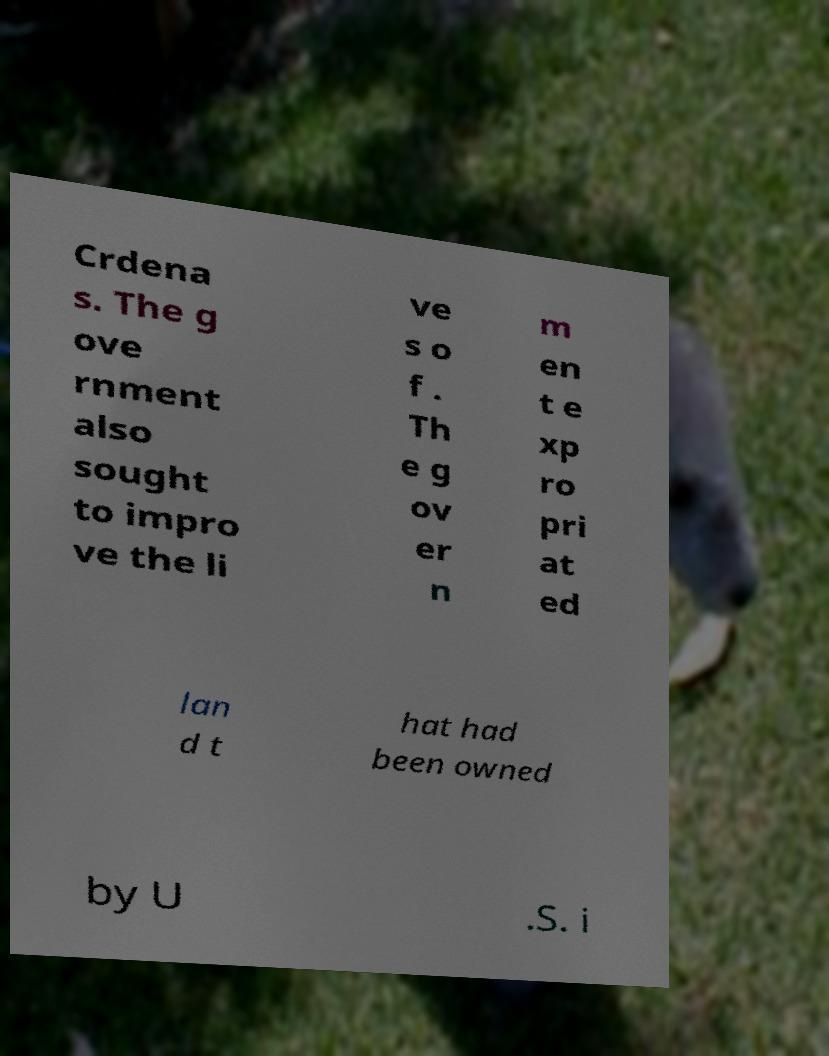Please identify and transcribe the text found in this image. Crdena s. The g ove rnment also sought to impro ve the li ve s o f . Th e g ov er n m en t e xp ro pri at ed lan d t hat had been owned by U .S. i 